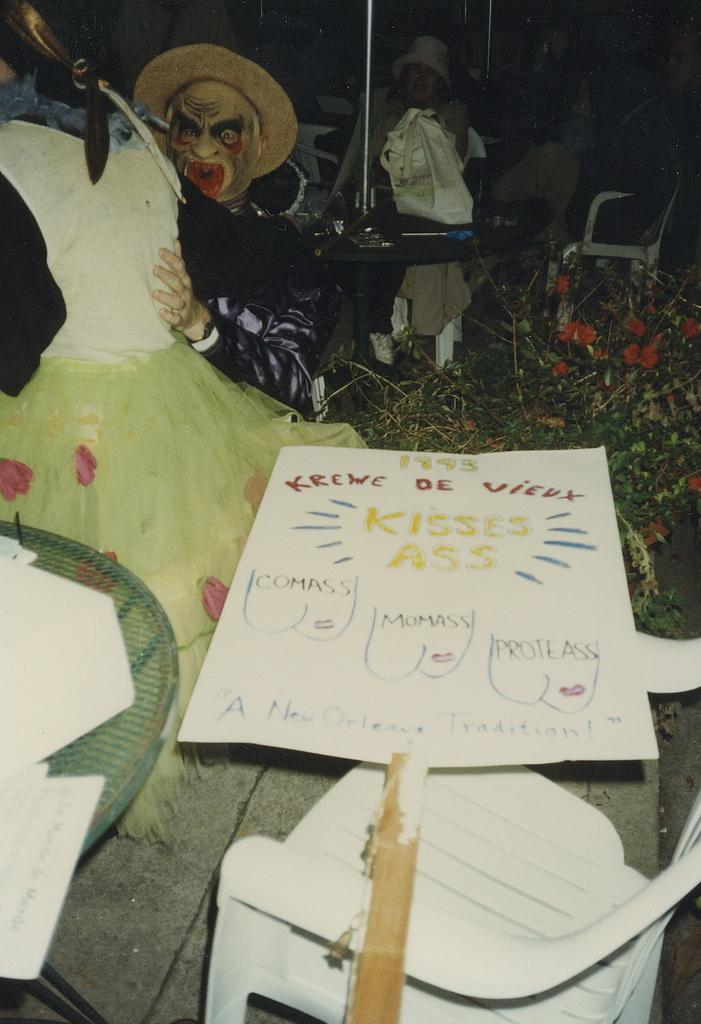Provide a one-sentence caption for the provided image. Tabletop with a white card and red words that say "Krewe De Vieux". 